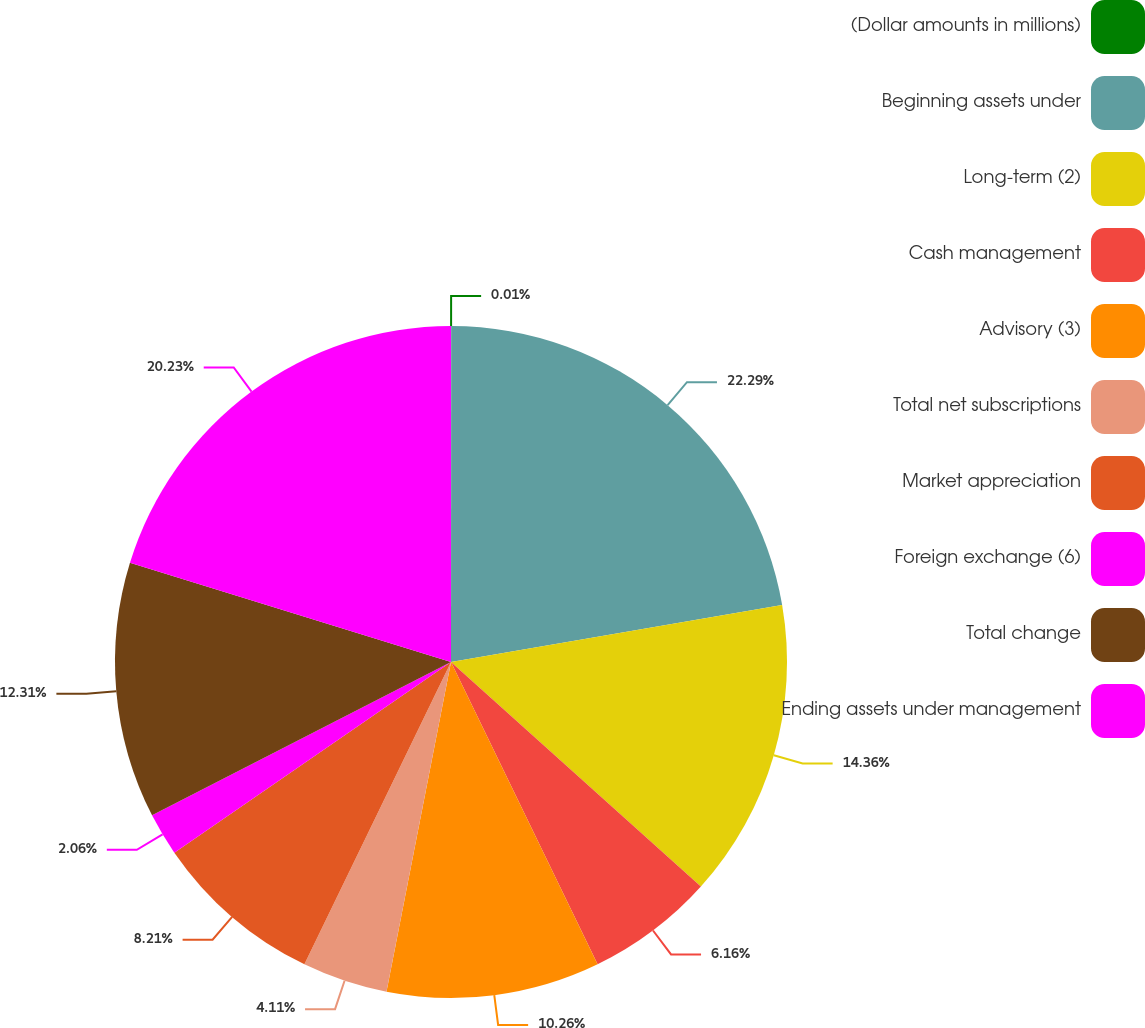Convert chart to OTSL. <chart><loc_0><loc_0><loc_500><loc_500><pie_chart><fcel>(Dollar amounts in millions)<fcel>Beginning assets under<fcel>Long-term (2)<fcel>Cash management<fcel>Advisory (3)<fcel>Total net subscriptions<fcel>Market appreciation<fcel>Foreign exchange (6)<fcel>Total change<fcel>Ending assets under management<nl><fcel>0.01%<fcel>22.28%<fcel>14.36%<fcel>6.16%<fcel>10.26%<fcel>4.11%<fcel>8.21%<fcel>2.06%<fcel>12.31%<fcel>20.23%<nl></chart> 